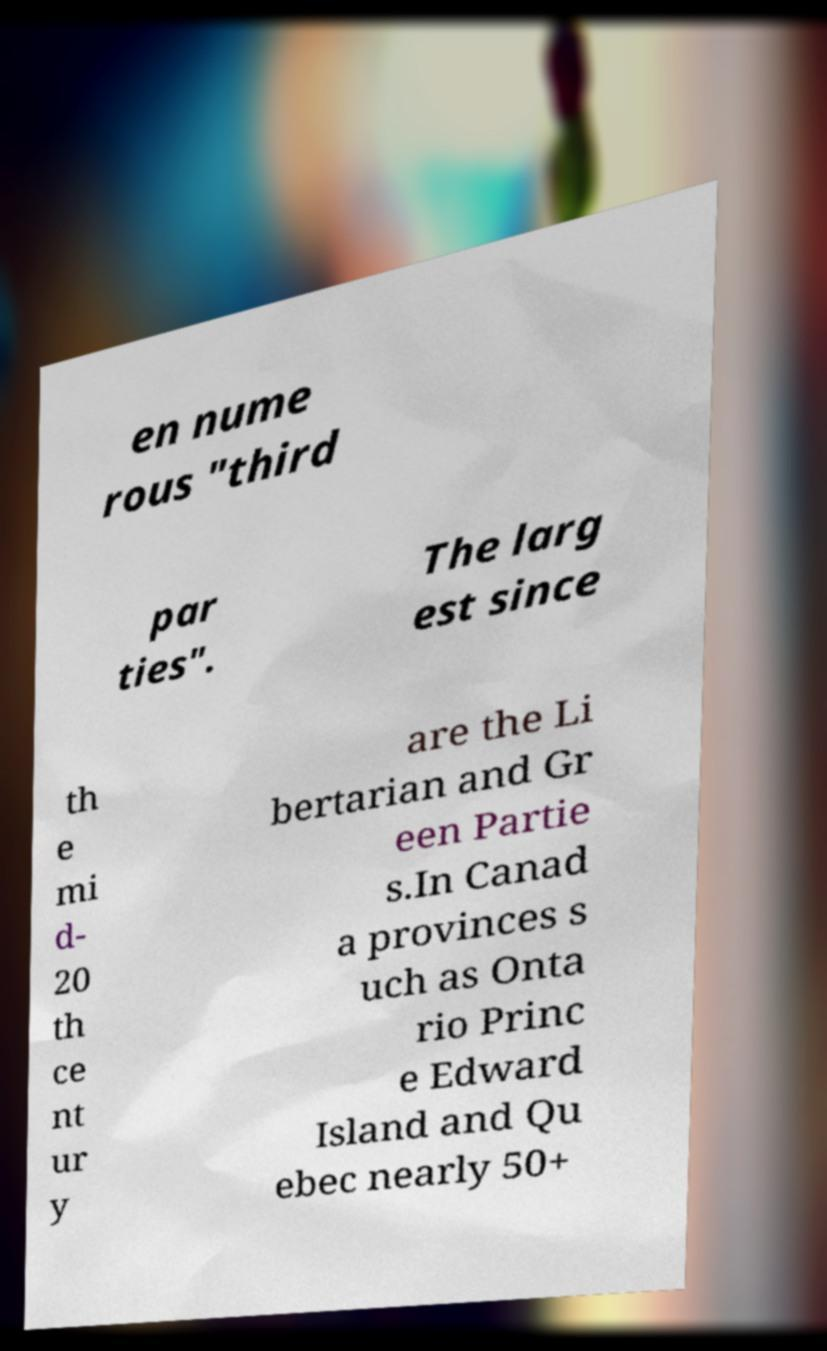There's text embedded in this image that I need extracted. Can you transcribe it verbatim? en nume rous "third par ties". The larg est since th e mi d- 20 th ce nt ur y are the Li bertarian and Gr een Partie s.In Canad a provinces s uch as Onta rio Princ e Edward Island and Qu ebec nearly 50+ 